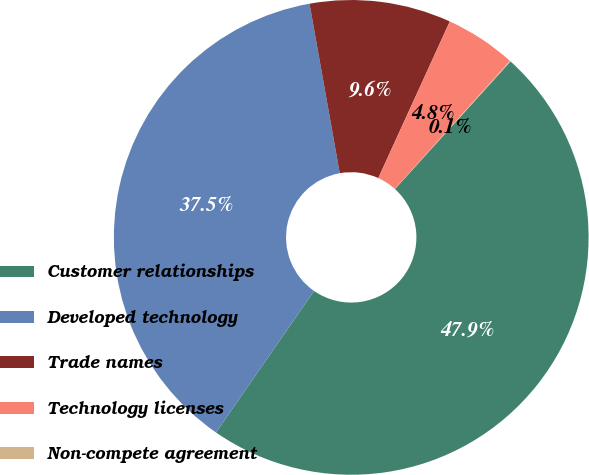Convert chart. <chart><loc_0><loc_0><loc_500><loc_500><pie_chart><fcel>Customer relationships<fcel>Developed technology<fcel>Trade names<fcel>Technology licenses<fcel>Non-compete agreement<nl><fcel>47.94%<fcel>37.54%<fcel>9.63%<fcel>4.84%<fcel>0.05%<nl></chart> 